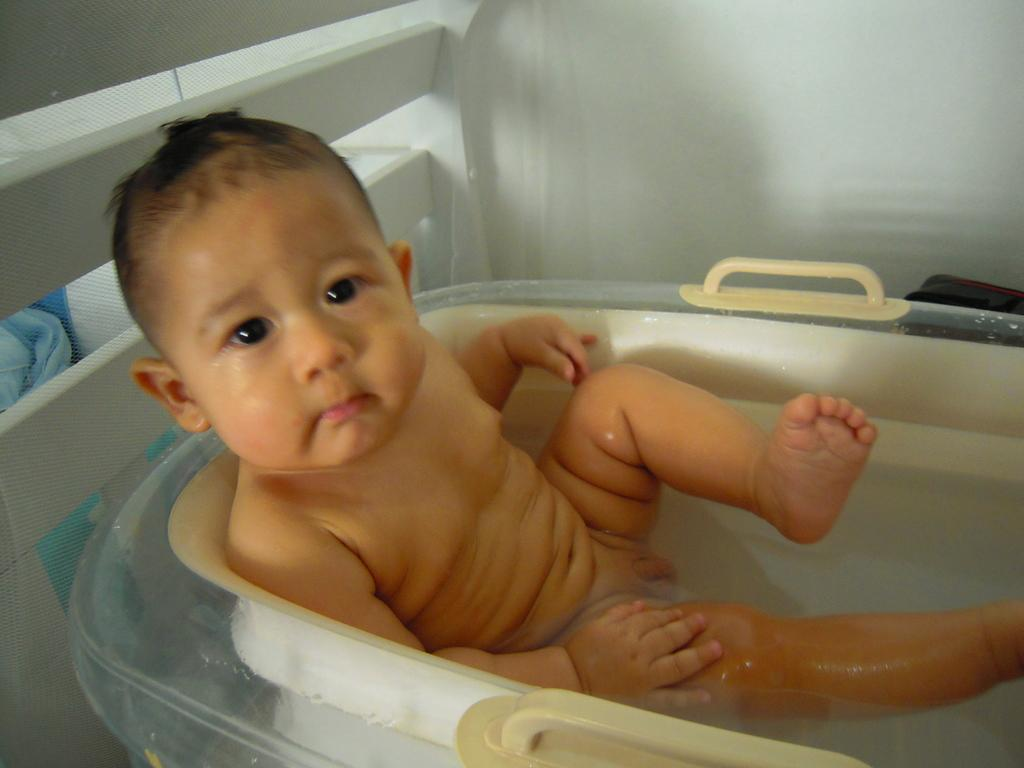What is the main subject of the image? There is a baby in the bathtub. What can be seen in the background of the image? There is a wall and mesh in the background of the image. Are there any other objects visible in the background? Yes, there are other objects in the background of the image. What type of page is the baby turning in the image? There is no page present in the image; it features a baby in a bathtub. Is there an owl attacking the baby in the image? No, there is no owl or any attack depicted in the image; it shows a baby in a bathtub with a background of a wall and mesh. 